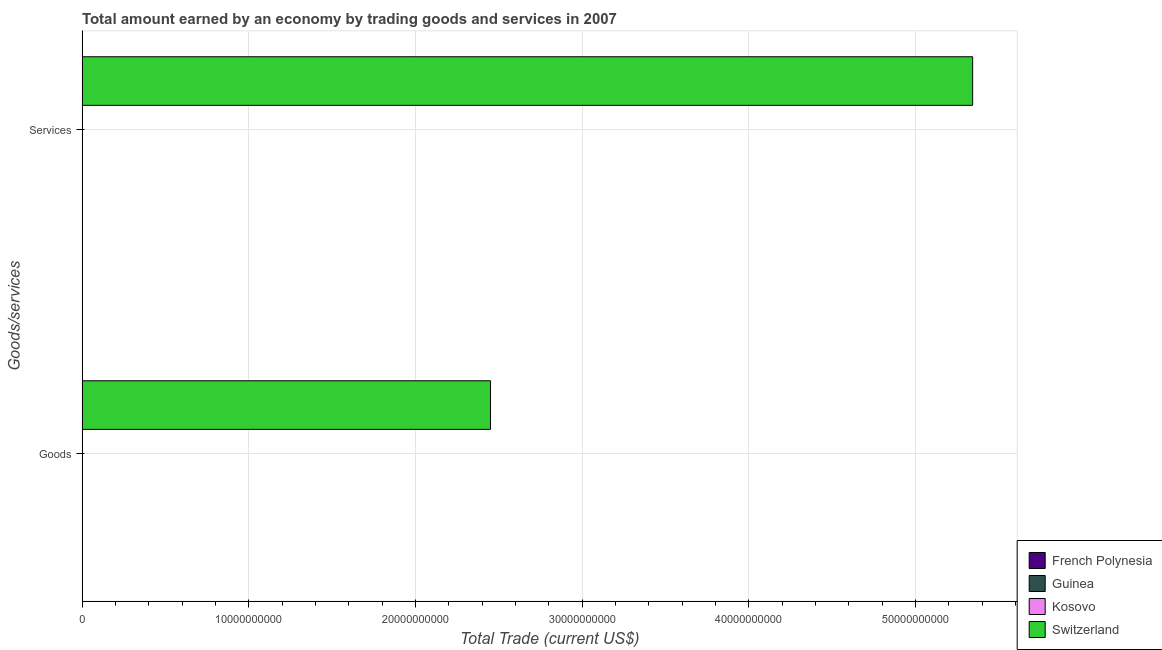How many different coloured bars are there?
Offer a terse response. 1. Are the number of bars per tick equal to the number of legend labels?
Give a very brief answer. No. How many bars are there on the 2nd tick from the top?
Your response must be concise. 1. What is the label of the 1st group of bars from the top?
Offer a terse response. Services. Across all countries, what is the maximum amount earned by trading goods?
Make the answer very short. 2.45e+1. Across all countries, what is the minimum amount earned by trading services?
Provide a short and direct response. 0. In which country was the amount earned by trading goods maximum?
Provide a succinct answer. Switzerland. What is the total amount earned by trading goods in the graph?
Offer a very short reply. 2.45e+1. What is the average amount earned by trading goods per country?
Ensure brevity in your answer.  6.13e+09. In how many countries, is the amount earned by trading goods greater than 44000000000 US$?
Keep it short and to the point. 0. Are all the bars in the graph horizontal?
Provide a short and direct response. Yes. How many countries are there in the graph?
Offer a terse response. 4. How many legend labels are there?
Your answer should be very brief. 4. How are the legend labels stacked?
Your response must be concise. Vertical. What is the title of the graph?
Provide a short and direct response. Total amount earned by an economy by trading goods and services in 2007. What is the label or title of the X-axis?
Ensure brevity in your answer.  Total Trade (current US$). What is the label or title of the Y-axis?
Provide a short and direct response. Goods/services. What is the Total Trade (current US$) in French Polynesia in Goods?
Provide a short and direct response. 0. What is the Total Trade (current US$) in Guinea in Goods?
Make the answer very short. 0. What is the Total Trade (current US$) of Switzerland in Goods?
Your answer should be compact. 2.45e+1. What is the Total Trade (current US$) in French Polynesia in Services?
Offer a terse response. 0. What is the Total Trade (current US$) of Kosovo in Services?
Offer a very short reply. 0. What is the Total Trade (current US$) in Switzerland in Services?
Ensure brevity in your answer.  5.34e+1. Across all Goods/services, what is the maximum Total Trade (current US$) in Switzerland?
Offer a very short reply. 5.34e+1. Across all Goods/services, what is the minimum Total Trade (current US$) in Switzerland?
Provide a short and direct response. 2.45e+1. What is the total Total Trade (current US$) in French Polynesia in the graph?
Keep it short and to the point. 0. What is the total Total Trade (current US$) of Guinea in the graph?
Give a very brief answer. 0. What is the total Total Trade (current US$) of Kosovo in the graph?
Offer a very short reply. 0. What is the total Total Trade (current US$) of Switzerland in the graph?
Provide a succinct answer. 7.79e+1. What is the difference between the Total Trade (current US$) of Switzerland in Goods and that in Services?
Your response must be concise. -2.89e+1. What is the average Total Trade (current US$) in French Polynesia per Goods/services?
Offer a very short reply. 0. What is the average Total Trade (current US$) of Switzerland per Goods/services?
Make the answer very short. 3.90e+1. What is the ratio of the Total Trade (current US$) of Switzerland in Goods to that in Services?
Give a very brief answer. 0.46. What is the difference between the highest and the second highest Total Trade (current US$) of Switzerland?
Provide a short and direct response. 2.89e+1. What is the difference between the highest and the lowest Total Trade (current US$) of Switzerland?
Ensure brevity in your answer.  2.89e+1. 